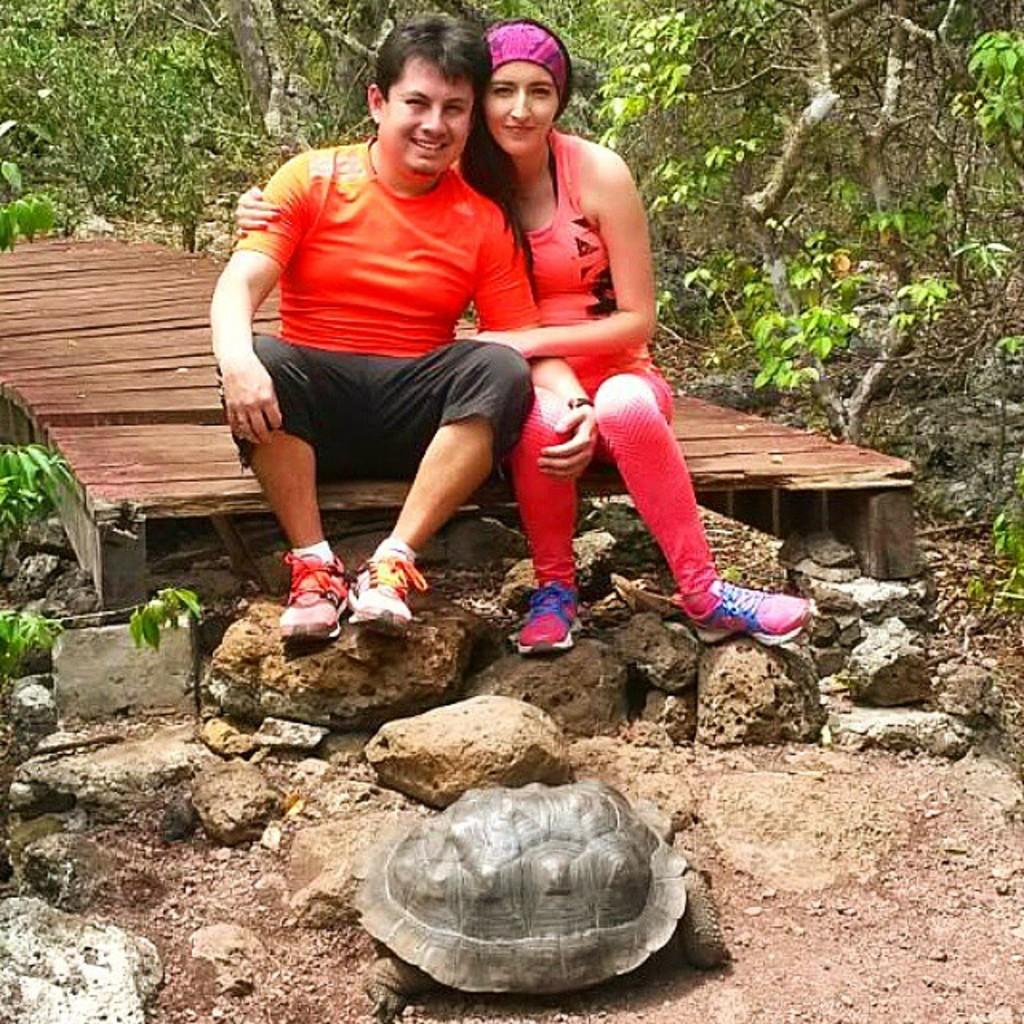How many people are in the image? There are two people in the image. What are the people doing in the image? The people are smiling in the image. Where are the people sitting? The people are sitting on a wooden platform. What is in front of the people? There are stones in front of the people. What animal can be seen on the ground? There is a tortoise on the ground. What can be seen in the background of the image? There are trees visible in the background. What type of mask is the beginner wearing in the image? There is no mask or beginner present in the image; it features two people smiling and a tortoise on the ground. Who is the manager in the image? There is no mention of a manager or any hierarchy in the image. 